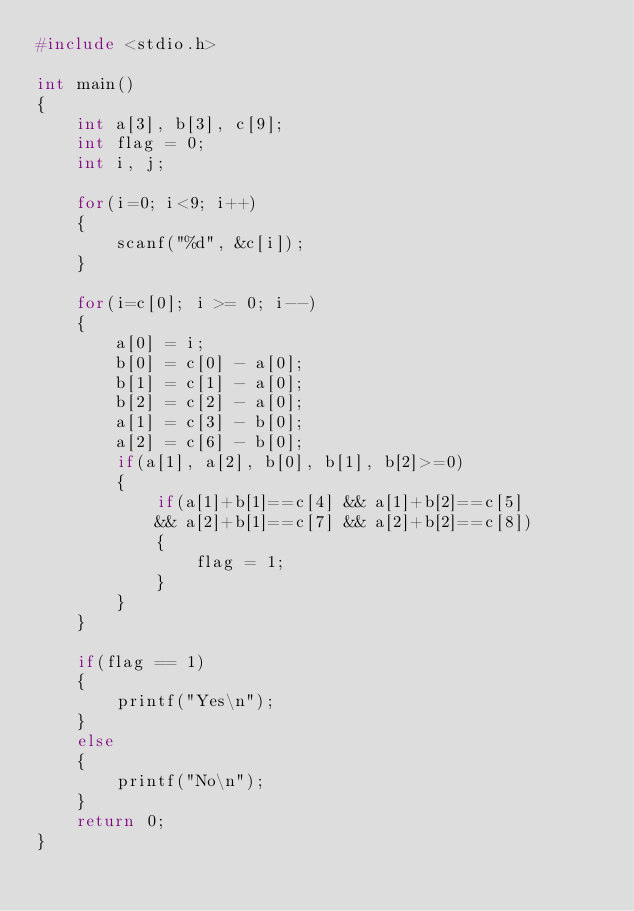<code> <loc_0><loc_0><loc_500><loc_500><_C_>#include <stdio.h>

int main()
{
    int a[3], b[3], c[9];
    int flag = 0;
    int i, j;

    for(i=0; i<9; i++)
    {
        scanf("%d", &c[i]);
    }

    for(i=c[0]; i >= 0; i--)
    {
        a[0] = i;
        b[0] = c[0] - a[0];
        b[1] = c[1] - a[0];
        b[2] = c[2] - a[0];
        a[1] = c[3] - b[0];
        a[2] = c[6] - b[0];
        if(a[1], a[2], b[0], b[1], b[2]>=0)
        {
            if(a[1]+b[1]==c[4] && a[1]+b[2]==c[5]
            && a[2]+b[1]==c[7] && a[2]+b[2]==c[8])
            {
                flag = 1;
            }
        }
    }

    if(flag == 1)
    {
        printf("Yes\n");
    }
    else
    {
        printf("No\n");
    }
    return 0;
}
</code> 